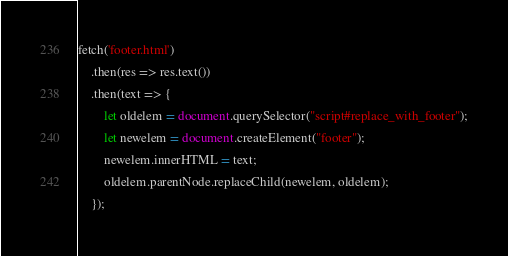Convert code to text. <code><loc_0><loc_0><loc_500><loc_500><_JavaScript_>fetch('footer.html')
    .then(res => res.text())
    .then(text => {
        let oldelem = document.querySelector("script#replace_with_footer");
        let newelem = document.createElement("footer");
        newelem.innerHTML = text;
        oldelem.parentNode.replaceChild(newelem, oldelem);
    });</code> 